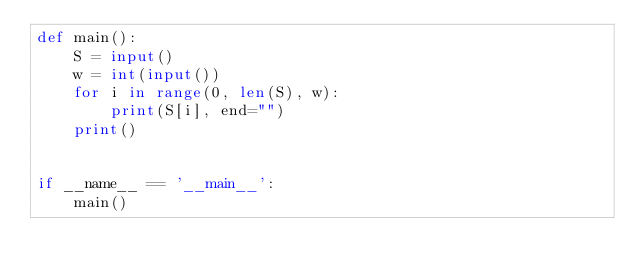Convert code to text. <code><loc_0><loc_0><loc_500><loc_500><_Python_>def main():
    S = input()
    w = int(input())
    for i in range(0, len(S), w):
        print(S[i], end="")
    print()


if __name__ == '__main__':
    main()
</code> 